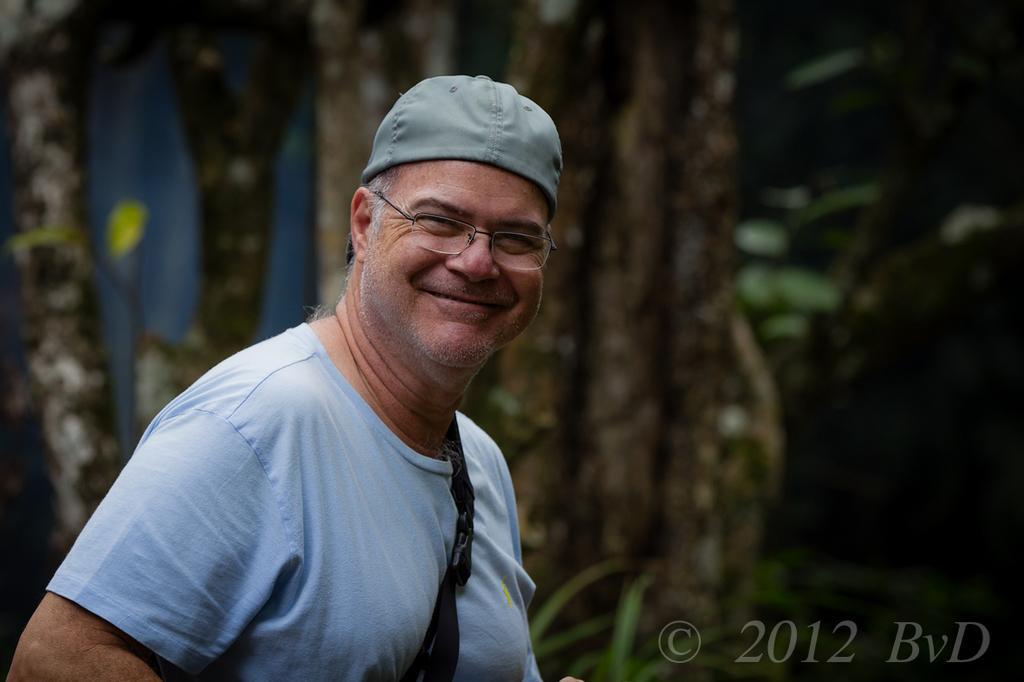Please provide a concise description of this image. In this picture, we see a man in the blue T-shirt is standing. He is wearing the spectacles and a cap. He is smiling and he is posing for the photo. In the background, we see the trees and this picture is blurred in the background. 